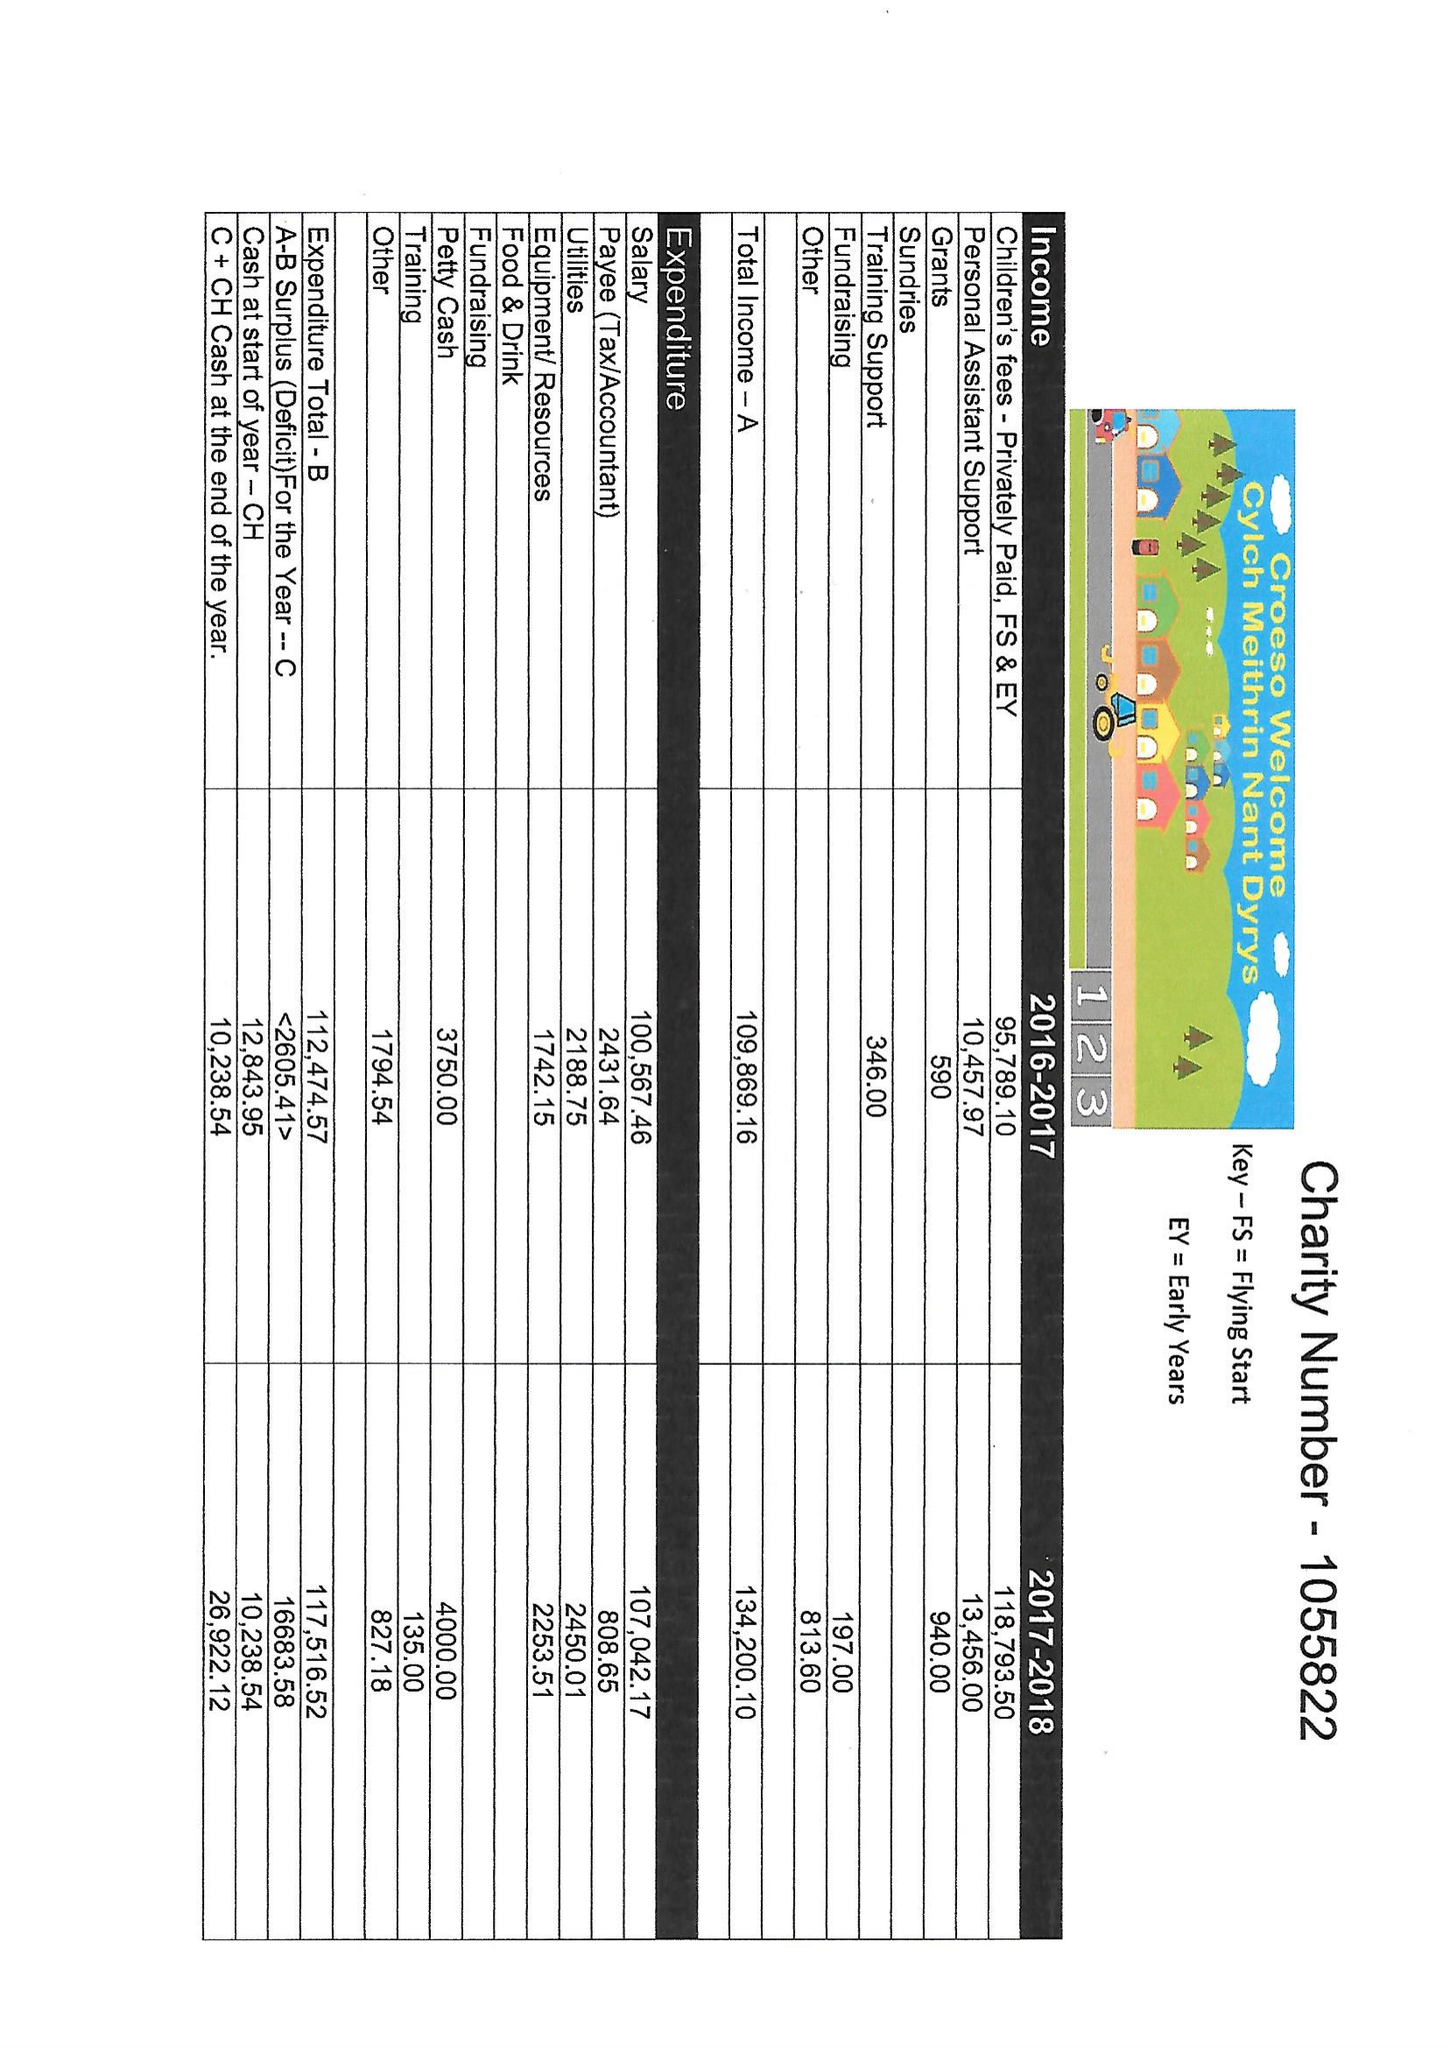What is the value for the report_date?
Answer the question using a single word or phrase. 2018-03-31 